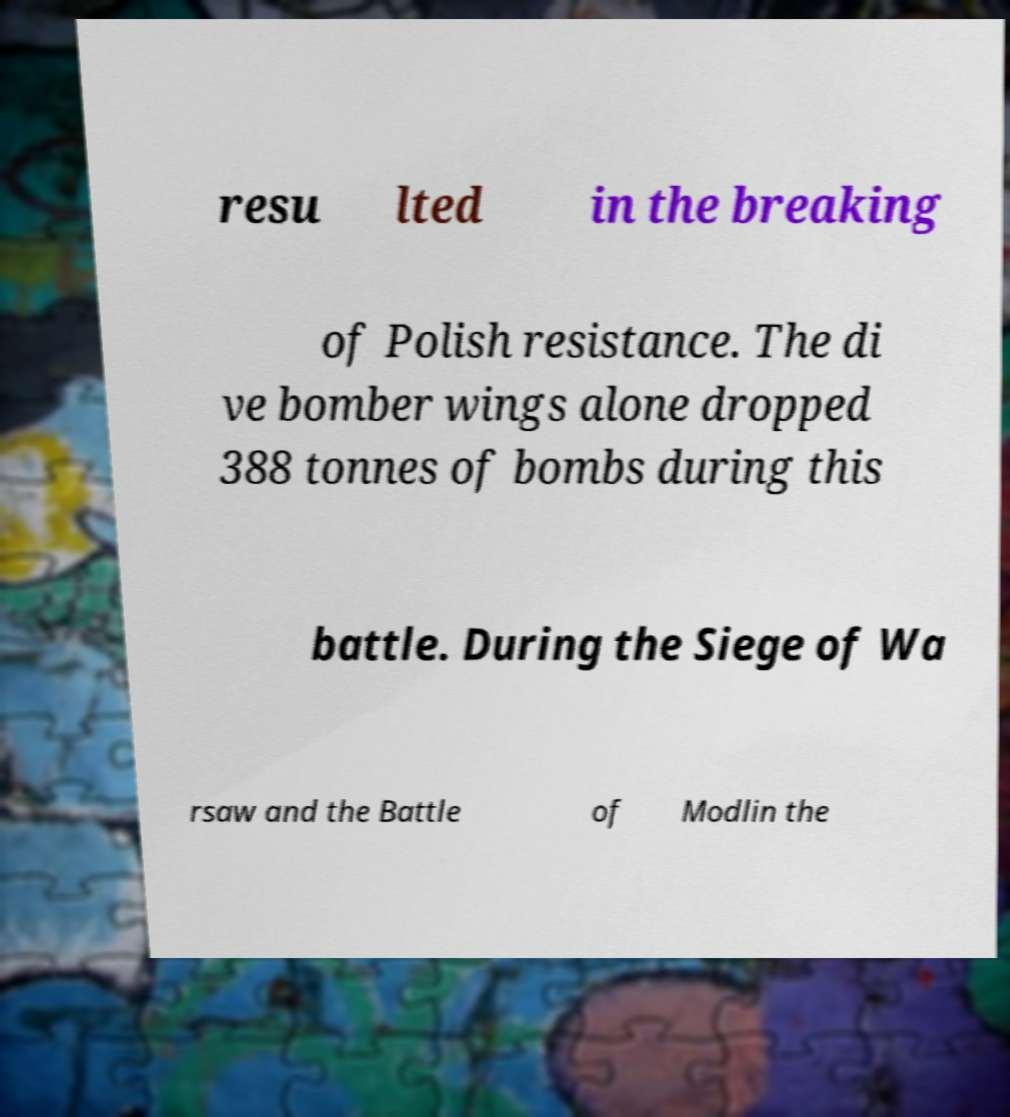Please identify and transcribe the text found in this image. resu lted in the breaking of Polish resistance. The di ve bomber wings alone dropped 388 tonnes of bombs during this battle. During the Siege of Wa rsaw and the Battle of Modlin the 